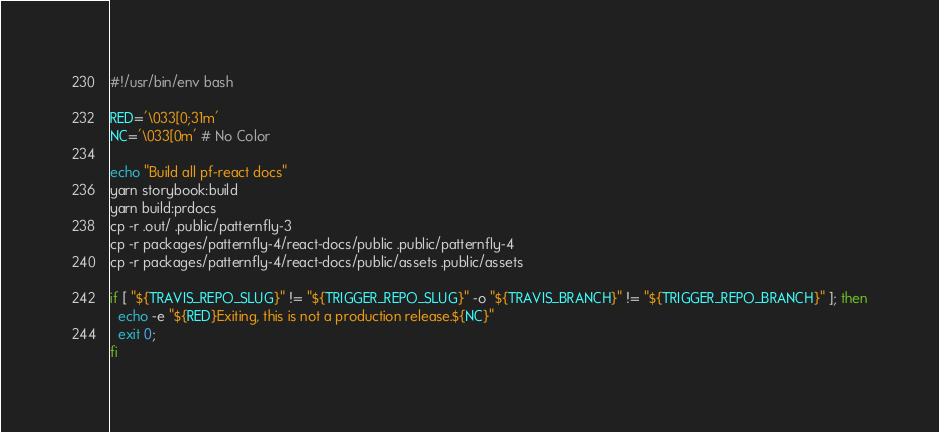Convert code to text. <code><loc_0><loc_0><loc_500><loc_500><_Bash_>#!/usr/bin/env bash

RED='\033[0;31m'
NC='\033[0m' # No Color

echo "Build all pf-react docs"
yarn storybook:build
yarn build:prdocs
cp -r .out/ .public/patternfly-3
cp -r packages/patternfly-4/react-docs/public .public/patternfly-4
cp -r packages/patternfly-4/react-docs/public/assets .public/assets

if [ "${TRAVIS_REPO_SLUG}" != "${TRIGGER_REPO_SLUG}" -o "${TRAVIS_BRANCH}" != "${TRIGGER_REPO_BRANCH}" ]; then
  echo -e "${RED}Exiting, this is not a production release.${NC}"
  exit 0;
fi
</code> 